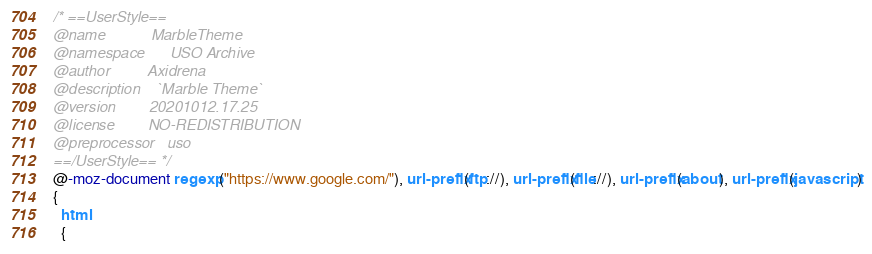<code> <loc_0><loc_0><loc_500><loc_500><_CSS_>/* ==UserStyle==
@name           MarbleTheme
@namespace      USO Archive
@author         Axidrena
@description    `Marble Theme`
@version        20201012.17.25
@license        NO-REDISTRIBUTION
@preprocessor   uso
==/UserStyle== */
@-moz-document regexp("https://www.google.com/"), url-prefix(ftp://), url-prefix(file://), url-prefix(about), url-prefix(javascript)
{
  html
  {</code> 